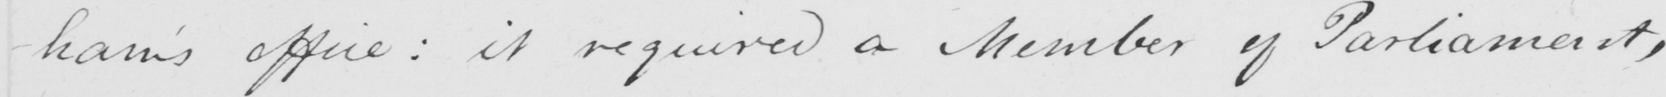What does this handwritten line say? -ham ' s office :  it required a Member of Parliament , 